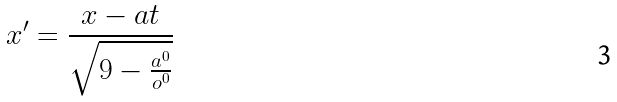<formula> <loc_0><loc_0><loc_500><loc_500>x ^ { \prime } = \frac { x - a t } { \sqrt { 9 - \frac { a ^ { 0 } } { o ^ { 0 } } } }</formula> 